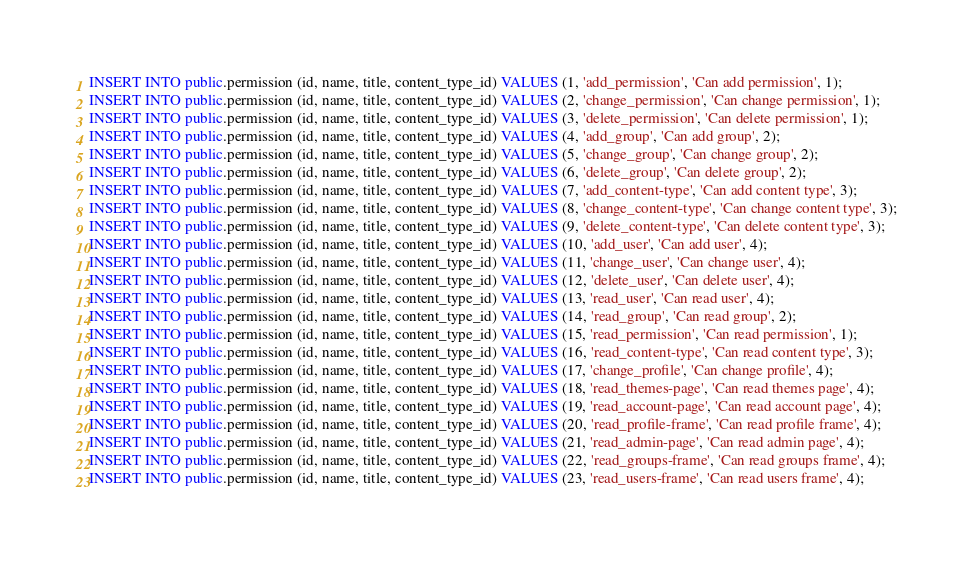Convert code to text. <code><loc_0><loc_0><loc_500><loc_500><_SQL_>INSERT INTO public.permission (id, name, title, content_type_id) VALUES (1, 'add_permission', 'Can add permission', 1);
INSERT INTO public.permission (id, name, title, content_type_id) VALUES (2, 'change_permission', 'Can change permission', 1);
INSERT INTO public.permission (id, name, title, content_type_id) VALUES (3, 'delete_permission', 'Can delete permission', 1);
INSERT INTO public.permission (id, name, title, content_type_id) VALUES (4, 'add_group', 'Can add group', 2);
INSERT INTO public.permission (id, name, title, content_type_id) VALUES (5, 'change_group', 'Can change group', 2);
INSERT INTO public.permission (id, name, title, content_type_id) VALUES (6, 'delete_group', 'Can delete group', 2);
INSERT INTO public.permission (id, name, title, content_type_id) VALUES (7, 'add_content-type', 'Can add content type', 3);
INSERT INTO public.permission (id, name, title, content_type_id) VALUES (8, 'change_content-type', 'Can change content type', 3);
INSERT INTO public.permission (id, name, title, content_type_id) VALUES (9, 'delete_content-type', 'Can delete content type', 3);
INSERT INTO public.permission (id, name, title, content_type_id) VALUES (10, 'add_user', 'Can add user', 4);
INSERT INTO public.permission (id, name, title, content_type_id) VALUES (11, 'change_user', 'Can change user', 4);
INSERT INTO public.permission (id, name, title, content_type_id) VALUES (12, 'delete_user', 'Can delete user', 4);
INSERT INTO public.permission (id, name, title, content_type_id) VALUES (13, 'read_user', 'Can read user', 4);
INSERT INTO public.permission (id, name, title, content_type_id) VALUES (14, 'read_group', 'Can read group', 2);
INSERT INTO public.permission (id, name, title, content_type_id) VALUES (15, 'read_permission', 'Can read permission', 1);
INSERT INTO public.permission (id, name, title, content_type_id) VALUES (16, 'read_content-type', 'Can read content type', 3);
INSERT INTO public.permission (id, name, title, content_type_id) VALUES (17, 'change_profile', 'Can change profile', 4);
INSERT INTO public.permission (id, name, title, content_type_id) VALUES (18, 'read_themes-page', 'Can read themes page', 4);
INSERT INTO public.permission (id, name, title, content_type_id) VALUES (19, 'read_account-page', 'Can read account page', 4);
INSERT INTO public.permission (id, name, title, content_type_id) VALUES (20, 'read_profile-frame', 'Can read profile frame', 4);
INSERT INTO public.permission (id, name, title, content_type_id) VALUES (21, 'read_admin-page', 'Can read admin page', 4);
INSERT INTO public.permission (id, name, title, content_type_id) VALUES (22, 'read_groups-frame', 'Can read groups frame', 4);
INSERT INTO public.permission (id, name, title, content_type_id) VALUES (23, 'read_users-frame', 'Can read users frame', 4);</code> 